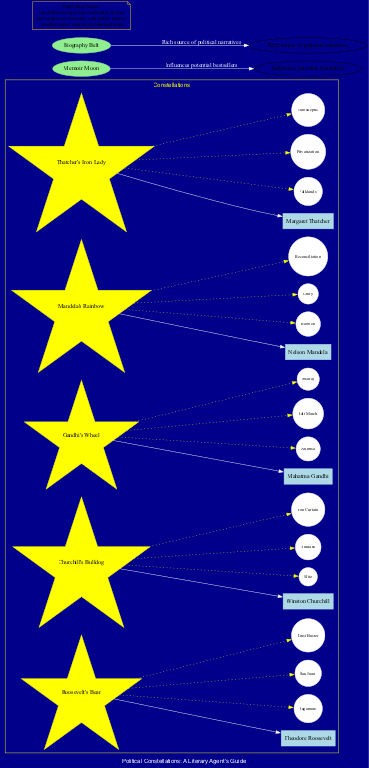What is the constellation associated with Theodore Roosevelt? The diagram shows a node labeled "Roosevelt's Bear" connected to the associated figure "Theodore Roosevelt". This indicates that "Roosevelt's Bear" is the corresponding constellation for him.
Answer: Roosevelt's Bear How many constellations are depicted in the diagram? By counting the nodes categorized under constellations, the diagram reveals a total of five distinct constellations listed.
Answer: 5 What notable star is associated with Gandhi's Wheel? The constellation "Gandhi's Wheel" has notable stars connected to it, one of which is "Ahimsa". Each star is a part of the specific constellation related to Mahatma Gandhi.
Answer: Ahimsa Which celestial body influences potential bestsellers? The diagram provides a node labeled "Memoir Moon," which explicitly describes its influence on potential bestsellers in a specific manner.
Answer: Memoir Moon What relationship exists between Churchill's Bulldog and the Iron Curtain? The diagram shows the connection of "Iron Curtain" as a notable star under the constellation "Churchill's Bulldog". This relationship indicates that the star "Iron Curtain" is specifically linked to Winston Churchill.
Answer: Churchill's Bulldog Identify the constellation that is represented by the associated figure described as the "Iron Lady". In the diagram, "Thatcher's Iron Lady" is the constellation depicted, corresponding to Margaret Thatcher as the political figure.
Answer: Thatcher's Iron Lady Which notable star signifies current public interest? The brightness of stars in the diagram correlates with public interest, as indicated in the publishing notes. "Falklands" is one of the notable stars under "Thatcher's Iron Lady," thus representing public interest.
Answer: Falklands What does the Biography Belt signify in the diagram? The node labeled "Biography Belt" is described as a rich source of political narratives, which suggests its significance in the context of political biographies and memoirs.
Answer: Rich source of political narratives How many notable stars are connected to Roosevelt's Bear? Upon reviewing the diagram for the constellation "Roosevelt's Bear", it shows three notable stars: "Sagamore", "San Juan", and "Trust Buster", thus totaling three stars.
Answer: 3 